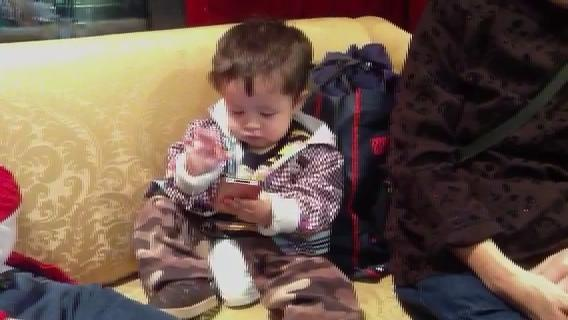What holiday is likely being celebrated here?

Choices:
A) christmas
B) april fools
C) columbus day
D) indigenous people's christmas 